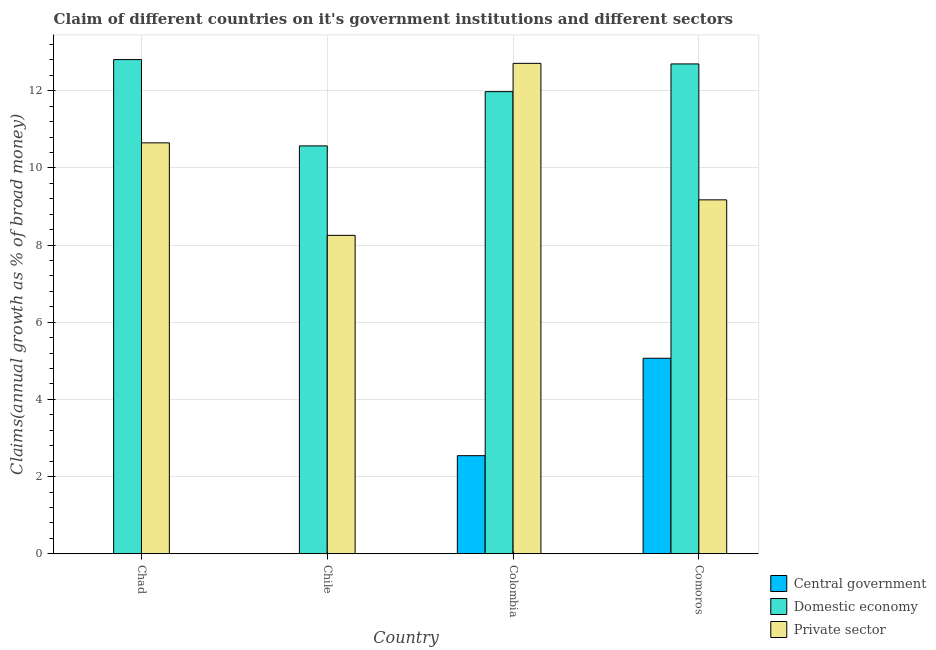How many different coloured bars are there?
Provide a succinct answer. 3. How many groups of bars are there?
Provide a succinct answer. 4. Are the number of bars on each tick of the X-axis equal?
Your answer should be compact. No. How many bars are there on the 4th tick from the left?
Offer a very short reply. 3. In how many cases, is the number of bars for a given country not equal to the number of legend labels?
Keep it short and to the point. 2. What is the percentage of claim on the domestic economy in Comoros?
Ensure brevity in your answer.  12.7. Across all countries, what is the maximum percentage of claim on the central government?
Provide a succinct answer. 5.07. Across all countries, what is the minimum percentage of claim on the central government?
Ensure brevity in your answer.  0. In which country was the percentage of claim on the private sector maximum?
Make the answer very short. Colombia. What is the total percentage of claim on the domestic economy in the graph?
Your answer should be compact. 48.06. What is the difference between the percentage of claim on the domestic economy in Chad and that in Comoros?
Offer a terse response. 0.11. What is the difference between the percentage of claim on the domestic economy in Comoros and the percentage of claim on the private sector in Chile?
Provide a succinct answer. 4.44. What is the average percentage of claim on the central government per country?
Keep it short and to the point. 1.9. What is the difference between the percentage of claim on the central government and percentage of claim on the private sector in Colombia?
Offer a terse response. -10.17. In how many countries, is the percentage of claim on the central government greater than 2.8 %?
Offer a terse response. 1. What is the ratio of the percentage of claim on the domestic economy in Colombia to that in Comoros?
Keep it short and to the point. 0.94. Is the difference between the percentage of claim on the private sector in Chile and Colombia greater than the difference between the percentage of claim on the domestic economy in Chile and Colombia?
Make the answer very short. No. What is the difference between the highest and the second highest percentage of claim on the private sector?
Your answer should be very brief. 2.06. What is the difference between the highest and the lowest percentage of claim on the domestic economy?
Offer a very short reply. 2.24. In how many countries, is the percentage of claim on the central government greater than the average percentage of claim on the central government taken over all countries?
Your answer should be very brief. 2. Is the sum of the percentage of claim on the domestic economy in Chad and Chile greater than the maximum percentage of claim on the central government across all countries?
Your answer should be compact. Yes. How many bars are there?
Your answer should be compact. 10. Are all the bars in the graph horizontal?
Give a very brief answer. No. How many countries are there in the graph?
Give a very brief answer. 4. Are the values on the major ticks of Y-axis written in scientific E-notation?
Offer a terse response. No. Does the graph contain any zero values?
Your answer should be compact. Yes. Does the graph contain grids?
Make the answer very short. Yes. Where does the legend appear in the graph?
Offer a very short reply. Bottom right. What is the title of the graph?
Ensure brevity in your answer.  Claim of different countries on it's government institutions and different sectors. Does "Agriculture" appear as one of the legend labels in the graph?
Offer a very short reply. No. What is the label or title of the Y-axis?
Your answer should be compact. Claims(annual growth as % of broad money). What is the Claims(annual growth as % of broad money) of Domestic economy in Chad?
Provide a succinct answer. 12.81. What is the Claims(annual growth as % of broad money) of Private sector in Chad?
Give a very brief answer. 10.65. What is the Claims(annual growth as % of broad money) in Central government in Chile?
Your answer should be compact. 0. What is the Claims(annual growth as % of broad money) in Domestic economy in Chile?
Give a very brief answer. 10.57. What is the Claims(annual growth as % of broad money) in Private sector in Chile?
Your answer should be very brief. 8.25. What is the Claims(annual growth as % of broad money) in Central government in Colombia?
Ensure brevity in your answer.  2.54. What is the Claims(annual growth as % of broad money) in Domestic economy in Colombia?
Offer a very short reply. 11.98. What is the Claims(annual growth as % of broad money) of Private sector in Colombia?
Provide a short and direct response. 12.71. What is the Claims(annual growth as % of broad money) in Central government in Comoros?
Offer a very short reply. 5.07. What is the Claims(annual growth as % of broad money) of Domestic economy in Comoros?
Offer a very short reply. 12.7. What is the Claims(annual growth as % of broad money) of Private sector in Comoros?
Offer a very short reply. 9.17. Across all countries, what is the maximum Claims(annual growth as % of broad money) in Central government?
Offer a very short reply. 5.07. Across all countries, what is the maximum Claims(annual growth as % of broad money) of Domestic economy?
Offer a very short reply. 12.81. Across all countries, what is the maximum Claims(annual growth as % of broad money) in Private sector?
Offer a very short reply. 12.71. Across all countries, what is the minimum Claims(annual growth as % of broad money) of Domestic economy?
Offer a very short reply. 10.57. Across all countries, what is the minimum Claims(annual growth as % of broad money) of Private sector?
Your answer should be very brief. 8.25. What is the total Claims(annual growth as % of broad money) of Central government in the graph?
Your answer should be very brief. 7.61. What is the total Claims(annual growth as % of broad money) in Domestic economy in the graph?
Give a very brief answer. 48.06. What is the total Claims(annual growth as % of broad money) in Private sector in the graph?
Make the answer very short. 40.79. What is the difference between the Claims(annual growth as % of broad money) in Domestic economy in Chad and that in Chile?
Your answer should be very brief. 2.24. What is the difference between the Claims(annual growth as % of broad money) in Private sector in Chad and that in Chile?
Keep it short and to the point. 2.4. What is the difference between the Claims(annual growth as % of broad money) of Domestic economy in Chad and that in Colombia?
Make the answer very short. 0.83. What is the difference between the Claims(annual growth as % of broad money) of Private sector in Chad and that in Colombia?
Offer a very short reply. -2.06. What is the difference between the Claims(annual growth as % of broad money) of Domestic economy in Chad and that in Comoros?
Your answer should be compact. 0.11. What is the difference between the Claims(annual growth as % of broad money) of Private sector in Chad and that in Comoros?
Provide a short and direct response. 1.48. What is the difference between the Claims(annual growth as % of broad money) in Domestic economy in Chile and that in Colombia?
Make the answer very short. -1.41. What is the difference between the Claims(annual growth as % of broad money) in Private sector in Chile and that in Colombia?
Give a very brief answer. -4.46. What is the difference between the Claims(annual growth as % of broad money) of Domestic economy in Chile and that in Comoros?
Your answer should be very brief. -2.12. What is the difference between the Claims(annual growth as % of broad money) in Private sector in Chile and that in Comoros?
Offer a terse response. -0.92. What is the difference between the Claims(annual growth as % of broad money) in Central government in Colombia and that in Comoros?
Offer a very short reply. -2.53. What is the difference between the Claims(annual growth as % of broad money) in Domestic economy in Colombia and that in Comoros?
Your answer should be compact. -0.72. What is the difference between the Claims(annual growth as % of broad money) of Private sector in Colombia and that in Comoros?
Provide a short and direct response. 3.54. What is the difference between the Claims(annual growth as % of broad money) in Domestic economy in Chad and the Claims(annual growth as % of broad money) in Private sector in Chile?
Ensure brevity in your answer.  4.56. What is the difference between the Claims(annual growth as % of broad money) of Domestic economy in Chad and the Claims(annual growth as % of broad money) of Private sector in Colombia?
Ensure brevity in your answer.  0.1. What is the difference between the Claims(annual growth as % of broad money) of Domestic economy in Chad and the Claims(annual growth as % of broad money) of Private sector in Comoros?
Your answer should be compact. 3.64. What is the difference between the Claims(annual growth as % of broad money) in Domestic economy in Chile and the Claims(annual growth as % of broad money) in Private sector in Colombia?
Keep it short and to the point. -2.14. What is the difference between the Claims(annual growth as % of broad money) in Domestic economy in Chile and the Claims(annual growth as % of broad money) in Private sector in Comoros?
Offer a very short reply. 1.4. What is the difference between the Claims(annual growth as % of broad money) in Central government in Colombia and the Claims(annual growth as % of broad money) in Domestic economy in Comoros?
Your answer should be very brief. -10.15. What is the difference between the Claims(annual growth as % of broad money) in Central government in Colombia and the Claims(annual growth as % of broad money) in Private sector in Comoros?
Ensure brevity in your answer.  -6.63. What is the difference between the Claims(annual growth as % of broad money) in Domestic economy in Colombia and the Claims(annual growth as % of broad money) in Private sector in Comoros?
Offer a terse response. 2.8. What is the average Claims(annual growth as % of broad money) in Central government per country?
Keep it short and to the point. 1.9. What is the average Claims(annual growth as % of broad money) in Domestic economy per country?
Ensure brevity in your answer.  12.01. What is the average Claims(annual growth as % of broad money) in Private sector per country?
Provide a short and direct response. 10.2. What is the difference between the Claims(annual growth as % of broad money) in Domestic economy and Claims(annual growth as % of broad money) in Private sector in Chad?
Your response must be concise. 2.16. What is the difference between the Claims(annual growth as % of broad money) of Domestic economy and Claims(annual growth as % of broad money) of Private sector in Chile?
Your answer should be very brief. 2.32. What is the difference between the Claims(annual growth as % of broad money) in Central government and Claims(annual growth as % of broad money) in Domestic economy in Colombia?
Your answer should be compact. -9.44. What is the difference between the Claims(annual growth as % of broad money) in Central government and Claims(annual growth as % of broad money) in Private sector in Colombia?
Provide a short and direct response. -10.17. What is the difference between the Claims(annual growth as % of broad money) in Domestic economy and Claims(annual growth as % of broad money) in Private sector in Colombia?
Your answer should be compact. -0.73. What is the difference between the Claims(annual growth as % of broad money) in Central government and Claims(annual growth as % of broad money) in Domestic economy in Comoros?
Your answer should be compact. -7.63. What is the difference between the Claims(annual growth as % of broad money) in Central government and Claims(annual growth as % of broad money) in Private sector in Comoros?
Your answer should be compact. -4.11. What is the difference between the Claims(annual growth as % of broad money) in Domestic economy and Claims(annual growth as % of broad money) in Private sector in Comoros?
Keep it short and to the point. 3.52. What is the ratio of the Claims(annual growth as % of broad money) of Domestic economy in Chad to that in Chile?
Provide a short and direct response. 1.21. What is the ratio of the Claims(annual growth as % of broad money) of Private sector in Chad to that in Chile?
Offer a terse response. 1.29. What is the ratio of the Claims(annual growth as % of broad money) of Domestic economy in Chad to that in Colombia?
Offer a very short reply. 1.07. What is the ratio of the Claims(annual growth as % of broad money) in Private sector in Chad to that in Colombia?
Your response must be concise. 0.84. What is the ratio of the Claims(annual growth as % of broad money) of Domestic economy in Chad to that in Comoros?
Provide a succinct answer. 1.01. What is the ratio of the Claims(annual growth as % of broad money) in Private sector in Chad to that in Comoros?
Your answer should be very brief. 1.16. What is the ratio of the Claims(annual growth as % of broad money) of Domestic economy in Chile to that in Colombia?
Ensure brevity in your answer.  0.88. What is the ratio of the Claims(annual growth as % of broad money) in Private sector in Chile to that in Colombia?
Your answer should be compact. 0.65. What is the ratio of the Claims(annual growth as % of broad money) of Domestic economy in Chile to that in Comoros?
Give a very brief answer. 0.83. What is the ratio of the Claims(annual growth as % of broad money) of Private sector in Chile to that in Comoros?
Provide a succinct answer. 0.9. What is the ratio of the Claims(annual growth as % of broad money) in Central government in Colombia to that in Comoros?
Make the answer very short. 0.5. What is the ratio of the Claims(annual growth as % of broad money) of Domestic economy in Colombia to that in Comoros?
Provide a succinct answer. 0.94. What is the ratio of the Claims(annual growth as % of broad money) in Private sector in Colombia to that in Comoros?
Provide a succinct answer. 1.39. What is the difference between the highest and the second highest Claims(annual growth as % of broad money) of Domestic economy?
Provide a succinct answer. 0.11. What is the difference between the highest and the second highest Claims(annual growth as % of broad money) of Private sector?
Keep it short and to the point. 2.06. What is the difference between the highest and the lowest Claims(annual growth as % of broad money) in Central government?
Your response must be concise. 5.07. What is the difference between the highest and the lowest Claims(annual growth as % of broad money) in Domestic economy?
Give a very brief answer. 2.24. What is the difference between the highest and the lowest Claims(annual growth as % of broad money) of Private sector?
Provide a succinct answer. 4.46. 